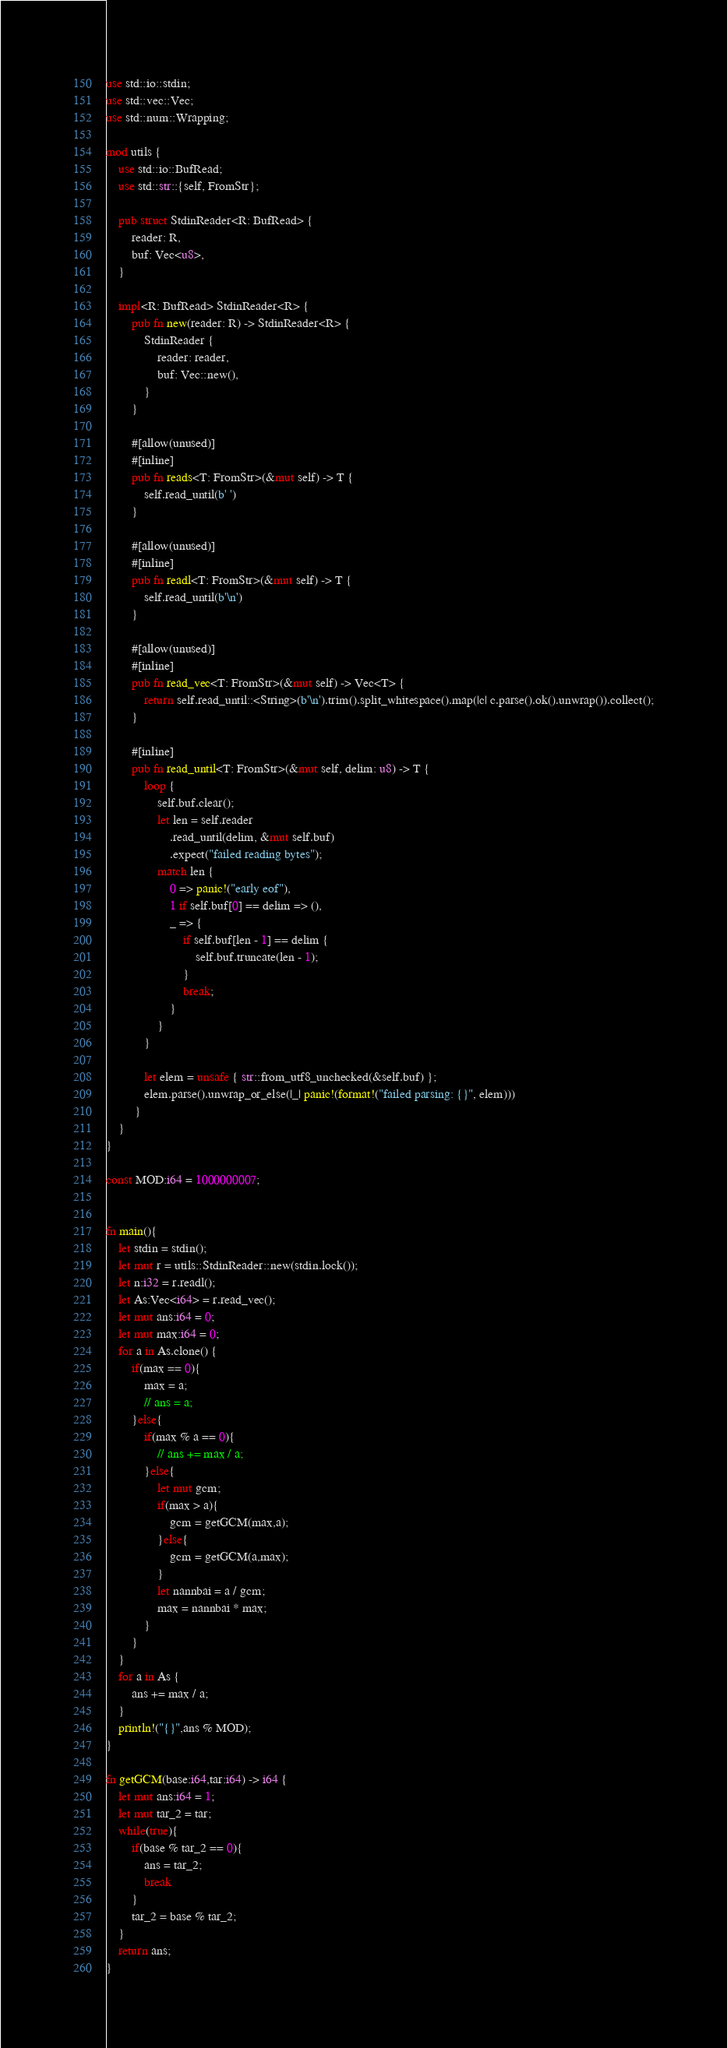Convert code to text. <code><loc_0><loc_0><loc_500><loc_500><_Rust_>use std::io::stdin;
use std::vec::Vec;
use std::num::Wrapping;

mod utils {
    use std::io::BufRead;
    use std::str::{self, FromStr};

    pub struct StdinReader<R: BufRead> {
        reader: R,
        buf: Vec<u8>,
    }

    impl<R: BufRead> StdinReader<R> {
        pub fn new(reader: R) -> StdinReader<R> {
            StdinReader {
                reader: reader,
                buf: Vec::new(),
            }
        }

        #[allow(unused)]
        #[inline]
        pub fn reads<T: FromStr>(&mut self) -> T {
            self.read_until(b' ')
        }

        #[allow(unused)]
        #[inline]
        pub fn readl<T: FromStr>(&mut self) -> T {
            self.read_until(b'\n')
        }

        #[allow(unused)]
        #[inline]
        pub fn read_vec<T: FromStr>(&mut self) -> Vec<T> {
            return self.read_until::<String>(b'\n').trim().split_whitespace().map(|c| c.parse().ok().unwrap()).collect();
        }

        #[inline]
        pub fn read_until<T: FromStr>(&mut self, delim: u8) -> T {
            loop {
                self.buf.clear();
                let len = self.reader
                    .read_until(delim, &mut self.buf)
                    .expect("failed reading bytes");
                match len {
                    0 => panic!("early eof"),
                    1 if self.buf[0] == delim => (),
                    _ => {
                        if self.buf[len - 1] == delim {
                            self.buf.truncate(len - 1);
                        }
                        break;
                    }
                }
            }

            let elem = unsafe { str::from_utf8_unchecked(&self.buf) };
            elem.parse().unwrap_or_else(|_| panic!(format!("failed parsing: {}", elem)))
         }
    }
}

const MOD:i64 = 1000000007;


fn main(){
    let stdin = stdin();
    let mut r = utils::StdinReader::new(stdin.lock());
    let n:i32 = r.readl();
    let As:Vec<i64> = r.read_vec();
    let mut ans:i64 = 0;
    let mut max:i64 = 0;
    for a in As.clone() {
        if(max == 0){
            max = a;
            // ans = a;
        }else{
            if(max % a == 0){
                // ans += max / a;
            }else{
                let mut gcm;
                if(max > a){
                    gcm = getGCM(max,a);
                }else{
                    gcm = getGCM(a,max);
                }
                let nannbai = a / gcm;
                max = nannbai * max;
            }
        }
    }
    for a in As {
        ans += max / a;
    }
    println!("{}",ans % MOD);
}

fn getGCM(base:i64,tar:i64) -> i64 {
    let mut ans:i64 = 1;
    let mut tar_2 = tar;
    while(true){
        if(base % tar_2 == 0){
            ans = tar_2;
            break
        }
        tar_2 = base % tar_2;
    }
    return ans;
}
</code> 